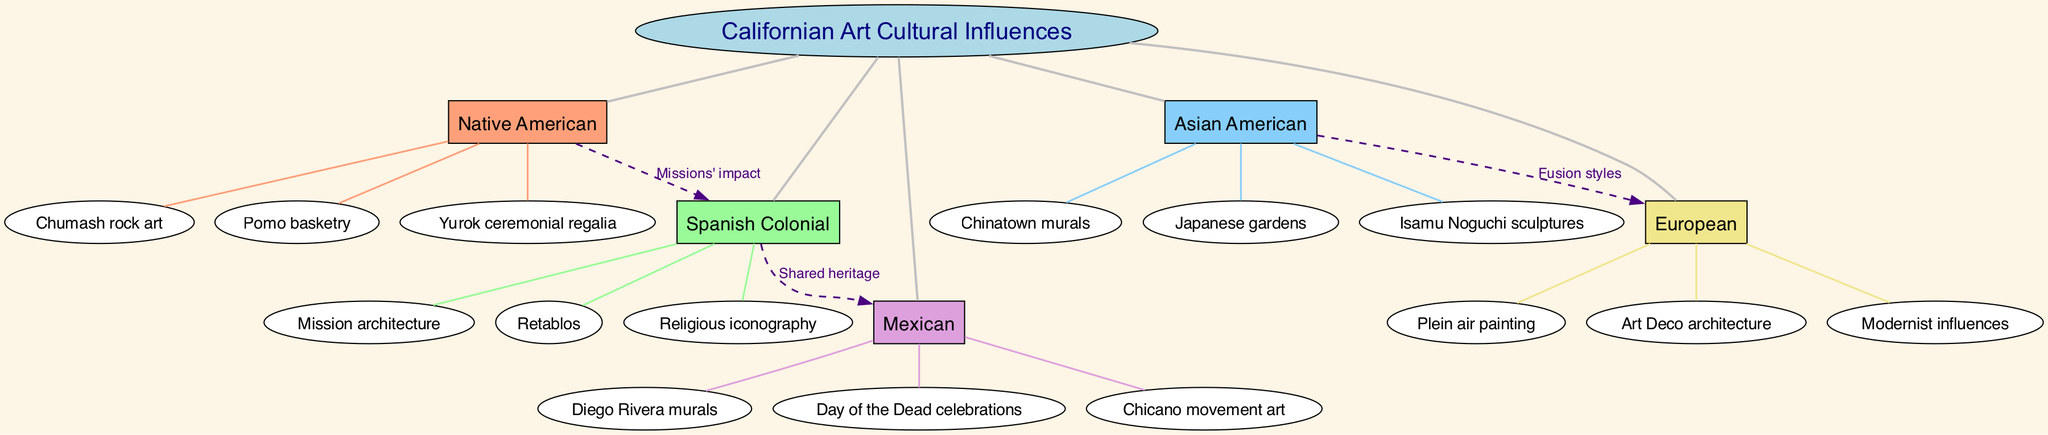What are the three sub-branches under Native American? The Native American branch lists three sub-branches: Chumash rock art, Pomo basketry, and Yurok ceremonial regalia. This can be directly identified in the diagram under the Native American section.
Answer: Chumash rock art, Pomo basketry, Yurok ceremonial regalia How many main branches are present in the diagram? The diagram includes five main branches: Native American, Spanish Colonial, Asian American, Mexican, and European. This can be counted directly by looking at the main branches section.
Answer: 5 What cultural influence does the label "Missions' impact" connect? The label "Missions' impact" connects Native American to Spanish Colonial, indicating a relationship based on the influence of missions on cultural exchange. This can be traced along the dashed line between those two branches.
Answer: Native American to Spanish Colonial Which branch has the sub-branch "Isamu Noguchi sculptures"? The sub-branch "Isamu Noguchi sculptures" belongs to the Asian American main branch. This can be verified by observing the listed sub-branches of the Asian American section.
Answer: Asian American Identify one type of art under the Mexican influence. "Diego Rivera murals" is a type of art under the Mexican influence. This is specifically noted as a sub-branch under the Mexican main branch in the diagram.
Answer: Diego Rivera murals How does the Spanish Colonial influence relate to the Mexican influence? The Spanish Colonial influence is connected to the Mexican influence through the label "Shared heritage," which describes their historical connection. This can be seen on the connecting edge between the two branches.
Answer: Shared heritage What is the common theme between Asian American and European branches? The common theme is the label "Fusion styles," indicating a blending of artistic influences from these cultures. This can be found connecting the two branches in the diagram.
Answer: Fusion styles Which artistic influence includes "Day of the Dead celebrations"? "Day of the Dead celebrations" is included under the Mexican main branch. This can be verified by looking at the sub-branches listed under that specific main branch.
Answer: Mexican 